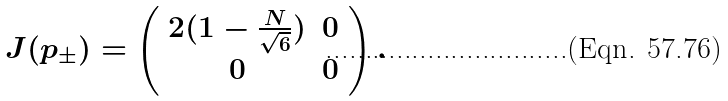Convert formula to latex. <formula><loc_0><loc_0><loc_500><loc_500>J ( p _ { \pm } ) = \left ( \begin{array} { c c } 2 ( 1 - \frac { N } { \sqrt { 6 } } ) & 0 \\ 0 & 0 \end{array} \right ) .</formula> 